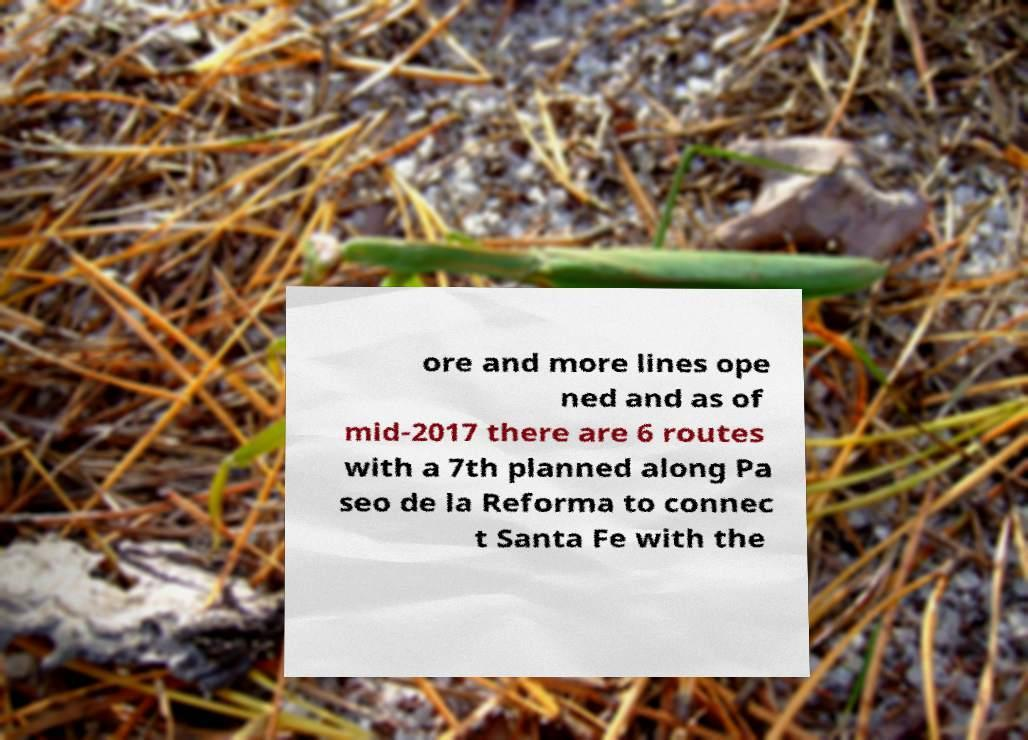Please read and relay the text visible in this image. What does it say? ore and more lines ope ned and as of mid-2017 there are 6 routes with a 7th planned along Pa seo de la Reforma to connec t Santa Fe with the 